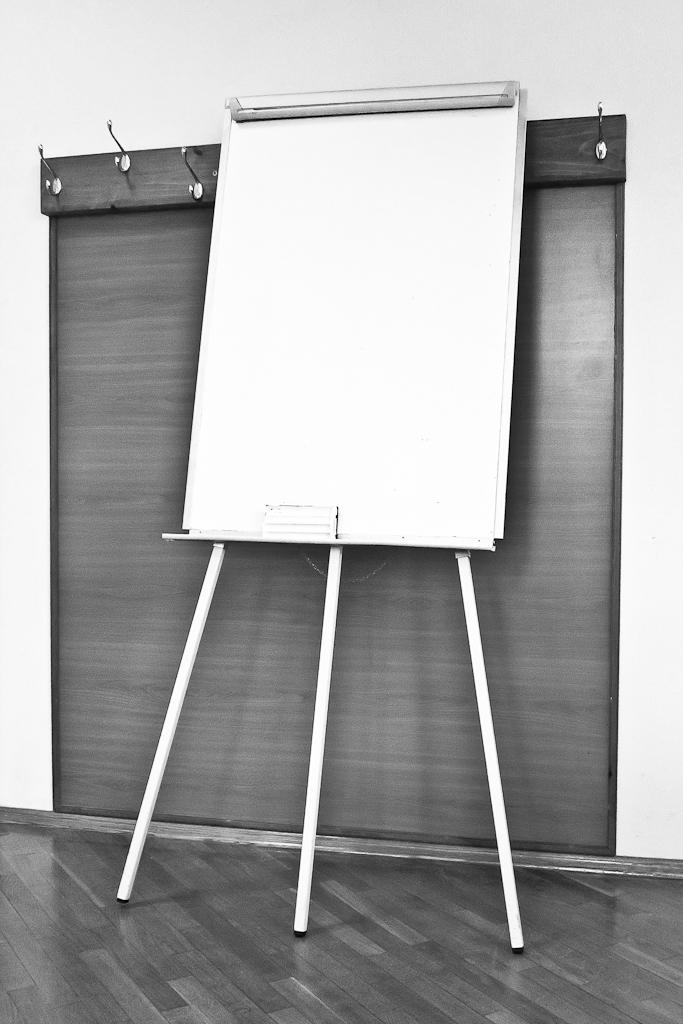What is the main object in the image? There is a board in the image. What can be seen in the background of the image? There are hangers and a wall in the background of the image. What is the color scheme of the image? The image is black and white. What type of meal is being prepared on the board in the image? There is no meal being prepared on the board in the image; it is a black and white image with a board and background elements. 